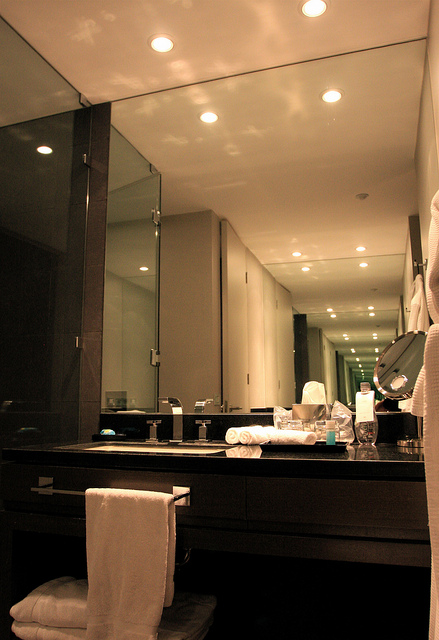What other elements of the bathroom design catch your eye, and how do they contribute to the overall atmosphere? The sleek, dark countertop and the modern sink fixtures immediately catch the eye, contributing significantly to the bathroom's luxurious and contemporary feel. The glass shower enclosure adds to the sense of openness, while the soft recessed lighting above the mirror creates a warm and inviting atmosphere. The neatly arranged toiletries and towels suggest a clean, organized space, enhancing functionality and comfort. Together, these elements work in harmony to create a sophisticated and relaxing environment. How does the lighting contribute to the functionality and design of the bathroom? The lighting in this bathroom is thoughtfully designed to enhance both functionality and aesthetics. Recessed ceiling lights provide ample illumination without cluttering the visual space, contributing to a sleek and clean design. Their strategic placement ensures even lighting across the room, making daily tasks such as grooming and cleaning easier and more efficient. Additionally, the interaction of light with the large mirror amplifies the brightness, creating a welcoming and spacious feel. This combination of functional and aesthetic lighting supports the modern, sophisticated ambiance of the bathroom. 